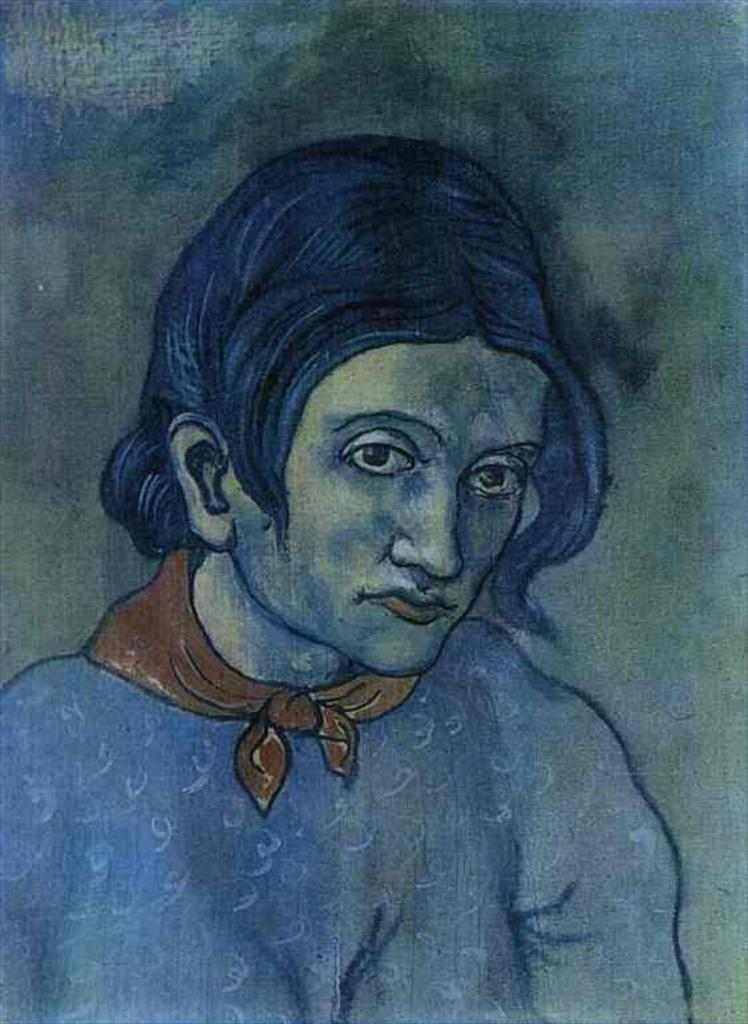What is the main subject of the image? The main subject of the image is an art piece of a person. What additional item can be seen in the image? There is a scarf in orange color in the image. What type of plantation is visible in the image? There is no plantation system present in the image. 